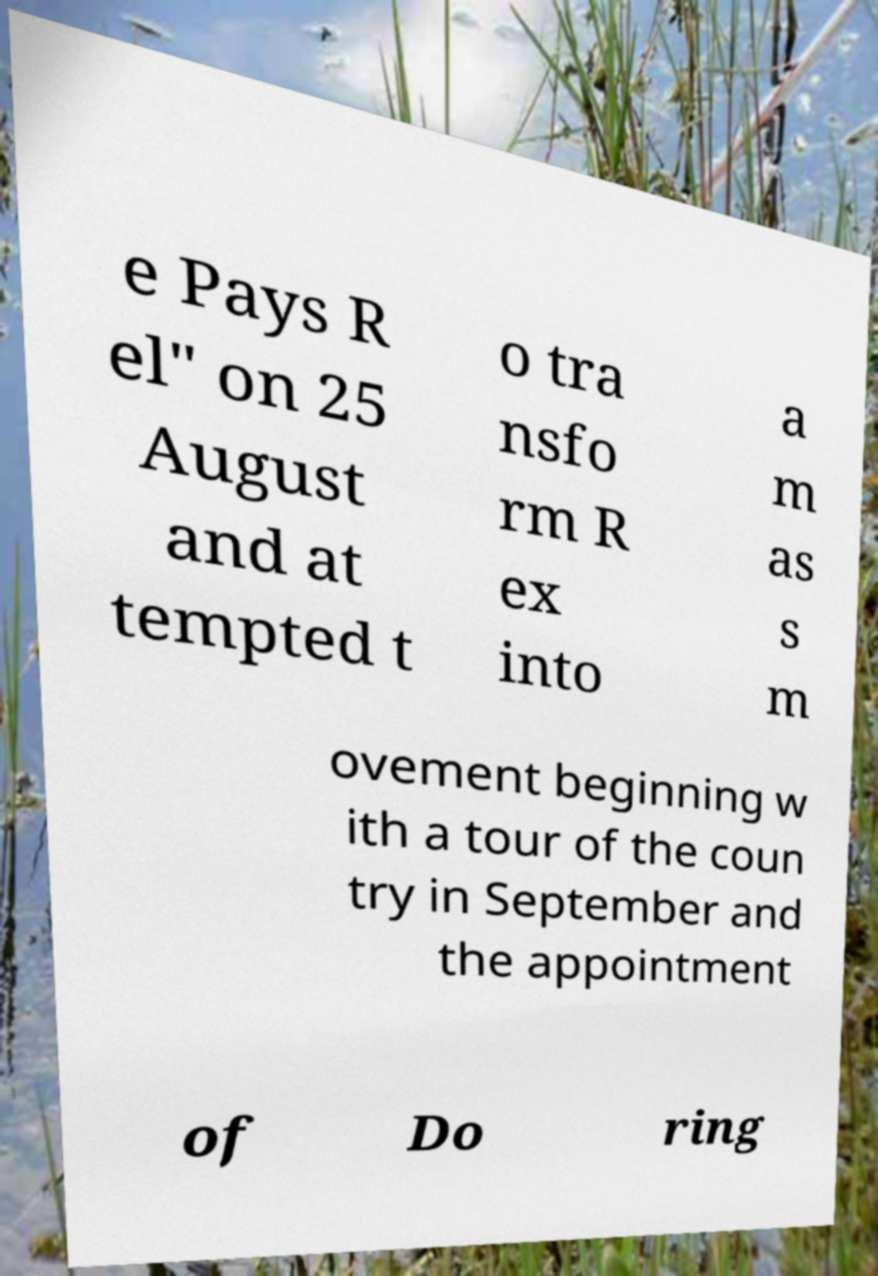Could you extract and type out the text from this image? e Pays R el" on 25 August and at tempted t o tra nsfo rm R ex into a m as s m ovement beginning w ith a tour of the coun try in September and the appointment of Do ring 